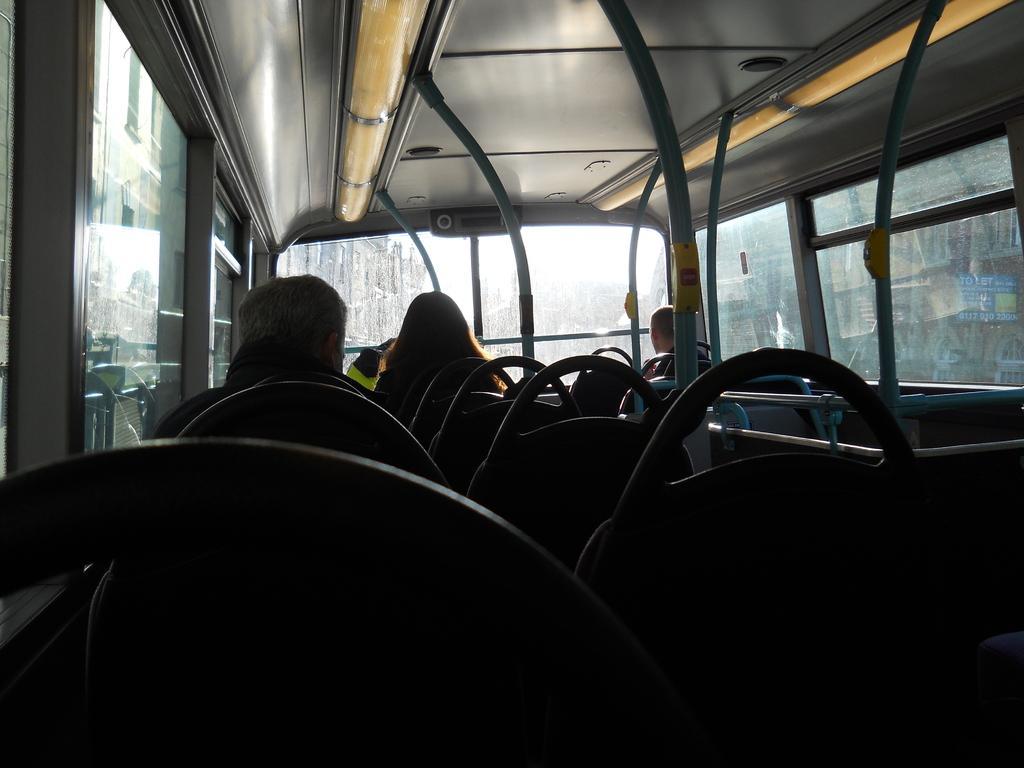How would you summarize this image in a sentence or two? In this image we can see the inner view of the motor vehicle. In the motor vehicle there are persons sitting in the seats. 